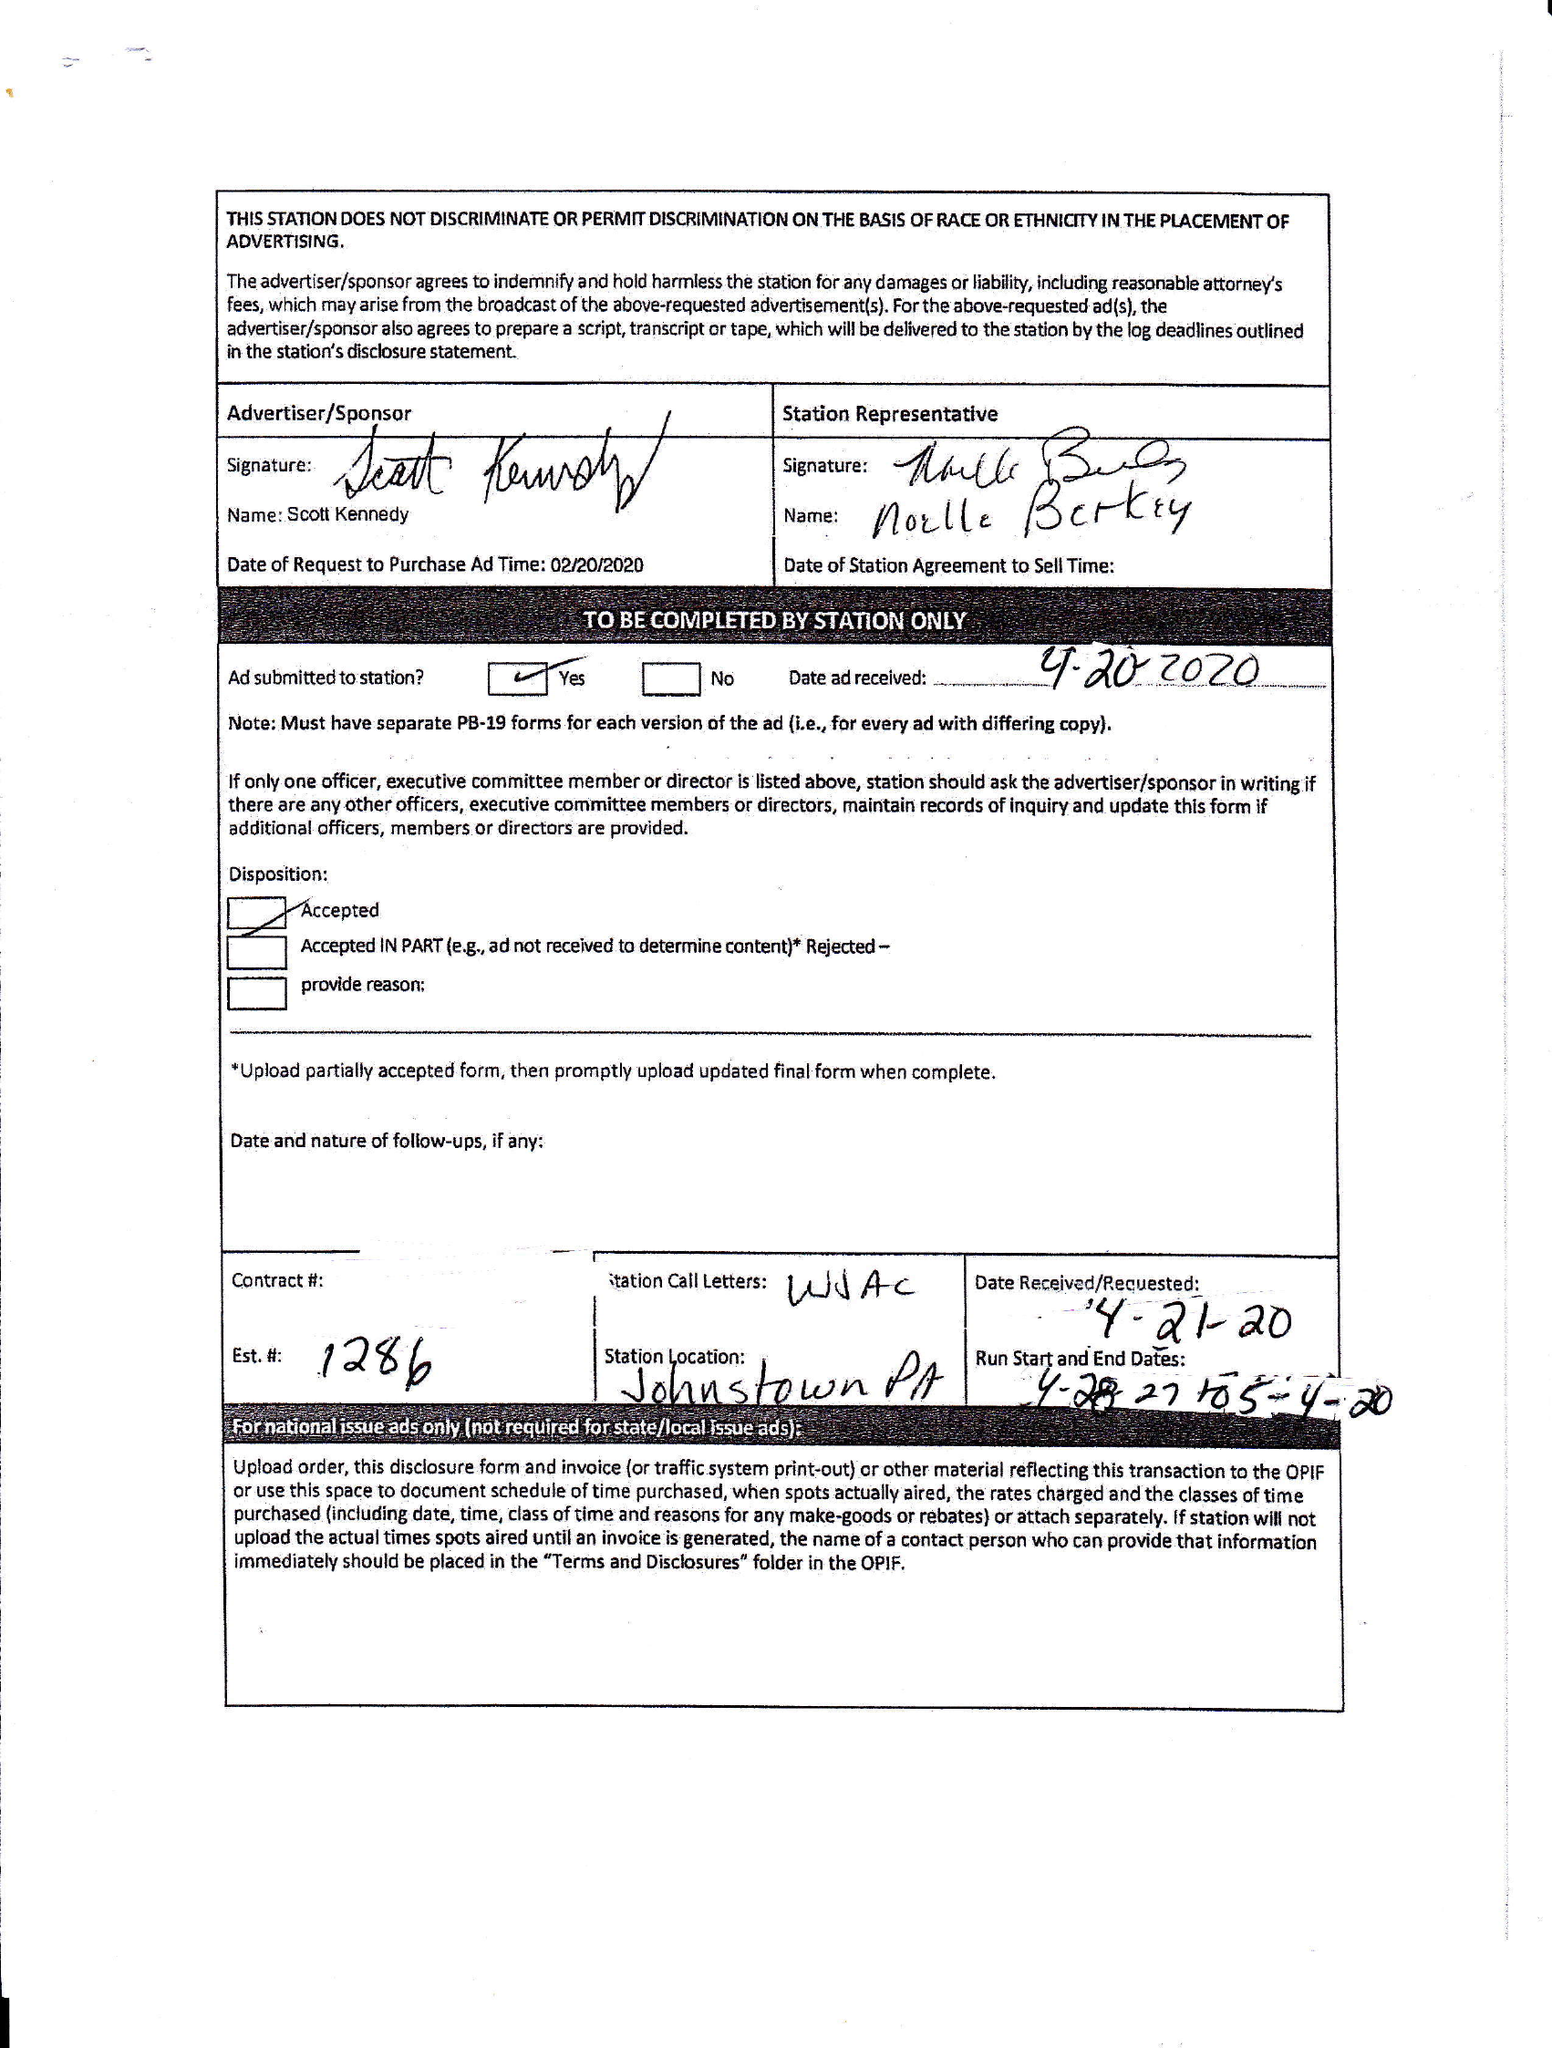What is the value for the advertiser?
Answer the question using a single word or phrase. SCOTT KENNEDY 